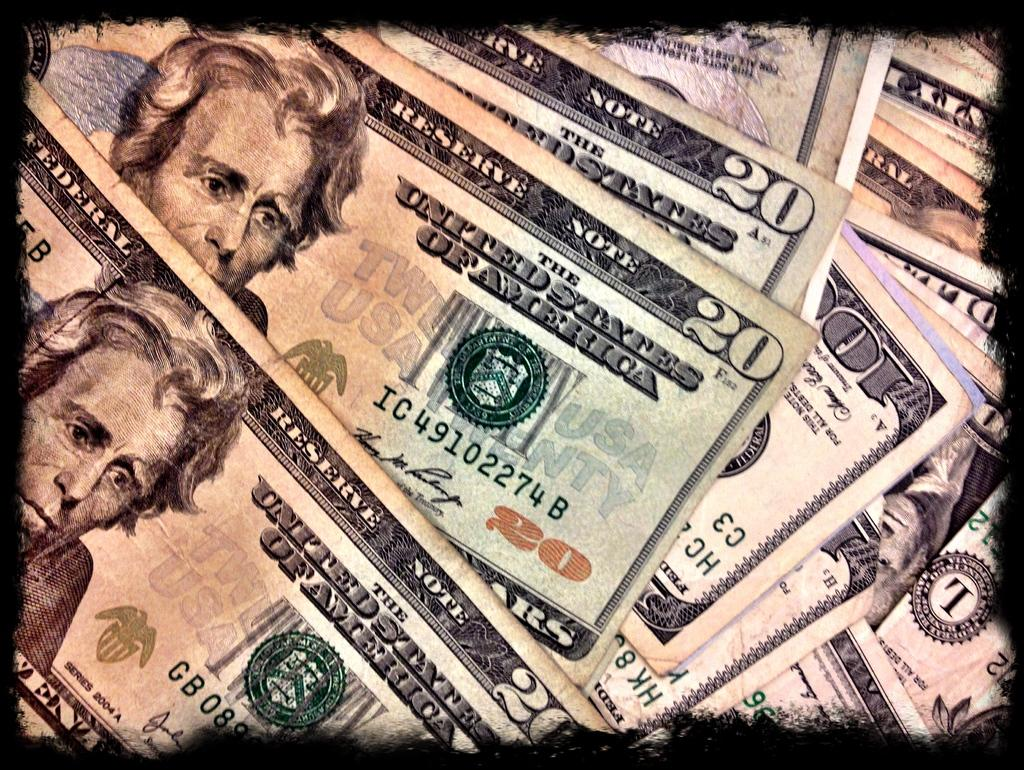What type of currency is present in the image? The image contains currency of the USA. What is the condition of the beggar's throat in the image? There is no beggar present in the image, and therefore no information about their throat can be provided. 